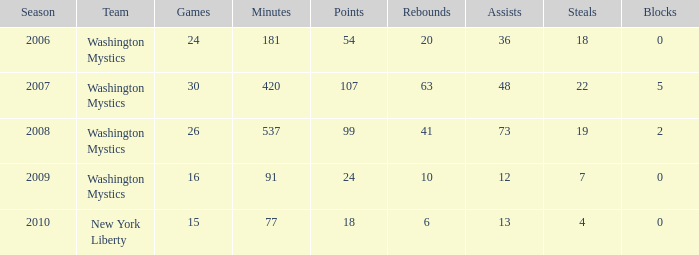When was the first year that assists were under 13 and minutes remained below 91? None. 